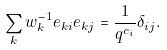Convert formula to latex. <formula><loc_0><loc_0><loc_500><loc_500>\sum _ { k } w _ { k } ^ { - 1 } e _ { k i } e _ { k j } = \frac { 1 } { q ^ { c _ { i } } } \delta _ { i j } .</formula> 